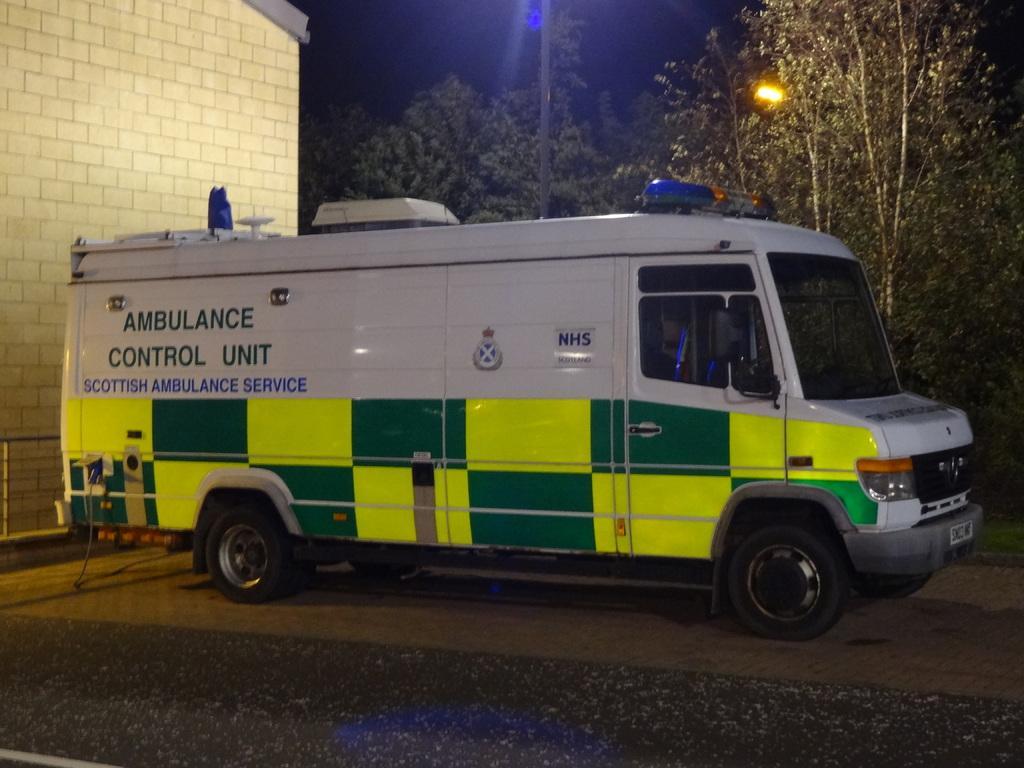Please provide a concise description of this image. It is an ambulance in white color, on the left side it is a hospital. There are trees in the middle of an image. 